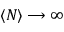Convert formula to latex. <formula><loc_0><loc_0><loc_500><loc_500>\langle N \rangle \longrightarrow \infty</formula> 